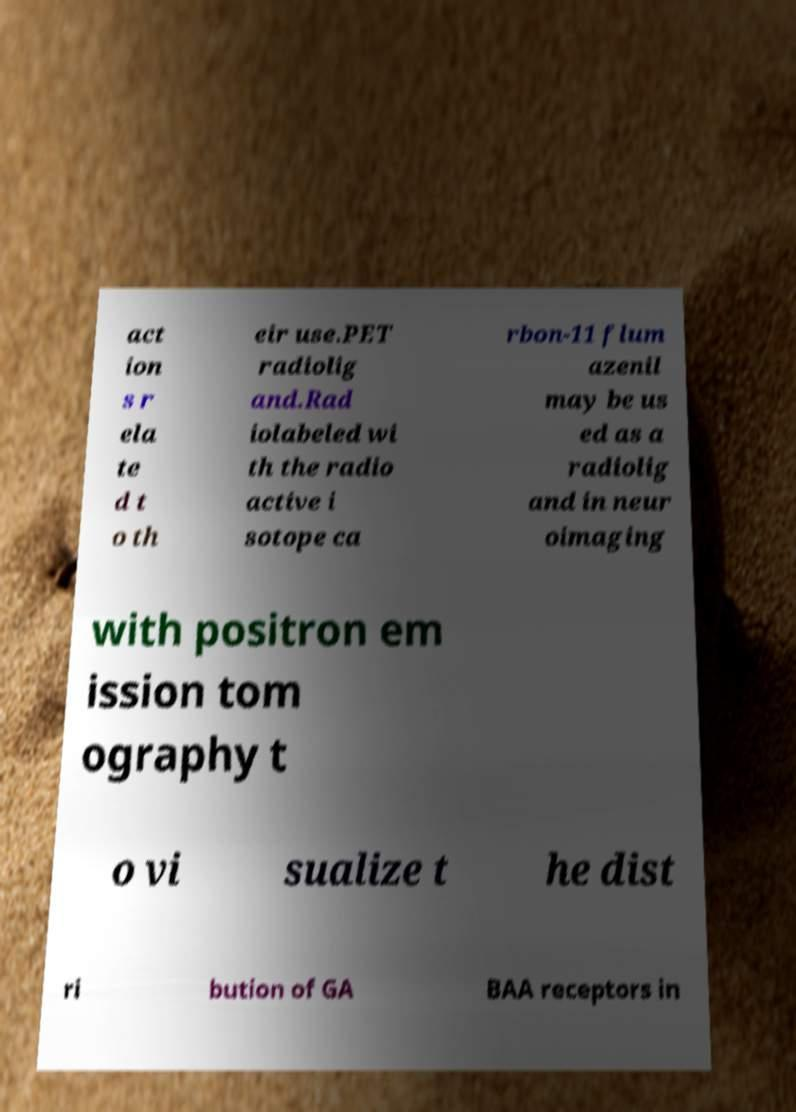I need the written content from this picture converted into text. Can you do that? act ion s r ela te d t o th eir use.PET radiolig and.Rad iolabeled wi th the radio active i sotope ca rbon-11 flum azenil may be us ed as a radiolig and in neur oimaging with positron em ission tom ography t o vi sualize t he dist ri bution of GA BAA receptors in 